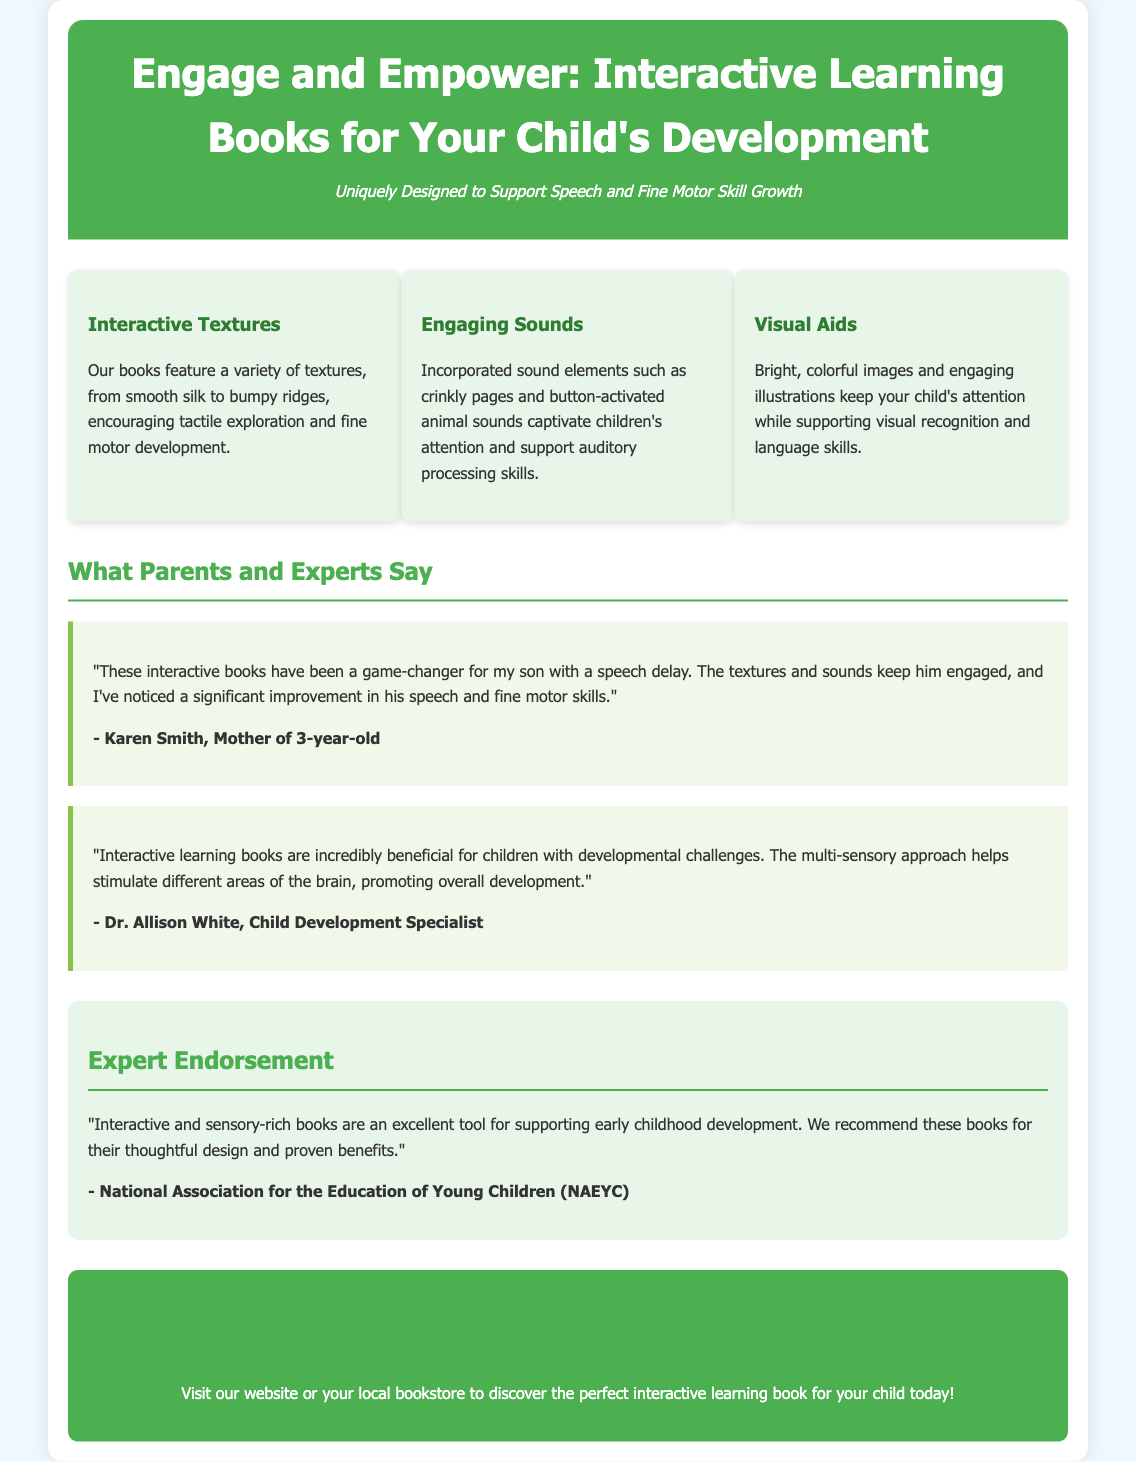What are the interactive elements featured in the books? The interactive elements include textures, sounds, and visual aids.
Answer: Textures, sounds, and visual aids Who provided a testimonial about the books being beneficial for speech delay? Karen Smith is the mother who provided a testimonial regarding the effectiveness of the books for her son.
Answer: Karen Smith What does Dr. Allison White say about the multi-sensory approach? She states that the multi-sensory approach helps stimulate different areas of the brain.
Answer: Stimulates different areas of the brain What endorsement did the National Association for the Education of Young Children give? They endorsed the books as an excellent tool for supporting early childhood development.
Answer: Excellent tool for supporting early childhood development How many features are highlighted in the document? The features discussed in the section include three distinct interactive elements.
Answer: Three What type of skills do the interactive texts encourage? The interactive texts encourage tactile exploration and fine motor development.
Answer: Fine motor development What kind of images are used in the interactive learning books? Bright, colorful images and engaging illustrations are used.
Answer: Bright, colorful images and engaging illustrations What is the main purpose of the Interactive Learning Books according to the header? The main purpose is to engage and empower children's development.
Answer: Engage and empower children's development 